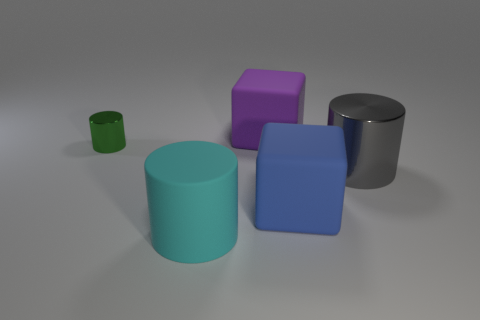Are there more small metallic cylinders than red rubber cylinders?
Provide a short and direct response. Yes. Is the size of the block behind the gray cylinder the same as the blue thing?
Your response must be concise. Yes. What number of matte cubes have the same color as the big rubber cylinder?
Offer a very short reply. 0. Do the purple object and the green shiny object have the same shape?
Ensure brevity in your answer.  No. Is there anything else that has the same size as the gray shiny object?
Your response must be concise. Yes. There is a green shiny object that is the same shape as the cyan matte thing; what is its size?
Make the answer very short. Small. Is the number of large blue objects that are behind the green shiny thing greater than the number of matte things that are in front of the large blue rubber block?
Your answer should be compact. No. Are the tiny green object and the big object that is behind the small cylinder made of the same material?
Keep it short and to the point. No. Is there anything else that is the same shape as the green shiny object?
Ensure brevity in your answer.  Yes. The big thing that is to the right of the big purple block and to the left of the big shiny thing is what color?
Offer a terse response. Blue. 